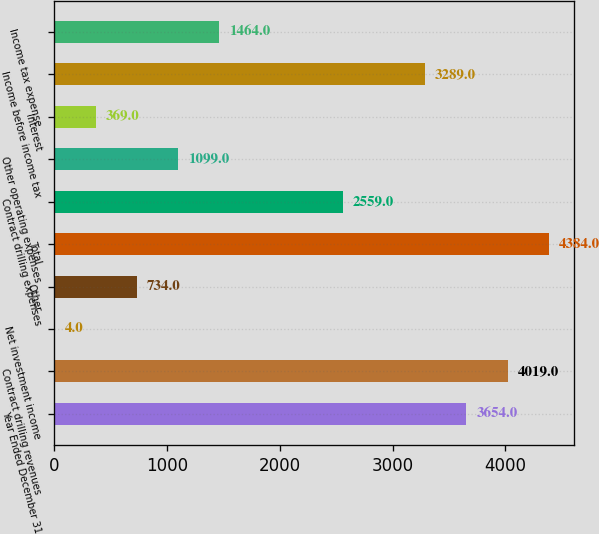Convert chart. <chart><loc_0><loc_0><loc_500><loc_500><bar_chart><fcel>Year Ended December 31<fcel>Contract drilling revenues<fcel>Net investment income<fcel>Other<fcel>Total<fcel>Contract drilling expenses<fcel>Other operating expenses<fcel>Interest<fcel>Income before income tax<fcel>Income tax expense<nl><fcel>3654<fcel>4019<fcel>4<fcel>734<fcel>4384<fcel>2559<fcel>1099<fcel>369<fcel>3289<fcel>1464<nl></chart> 